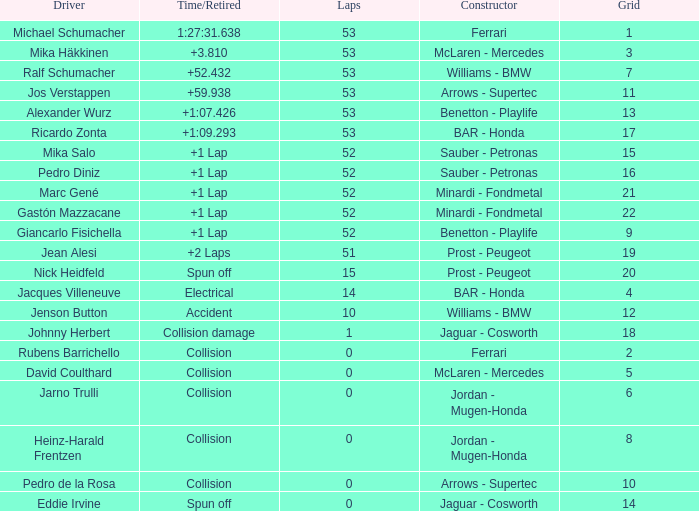What is the average Laps for a grid smaller than 17, and a Constructor of williams - bmw, driven by jenson button? 10.0. 